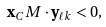Convert formula to latex. <formula><loc_0><loc_0><loc_500><loc_500>\mathbf x _ { C } M \cdot \mathbf y _ { \ell k } < 0 ,</formula> 